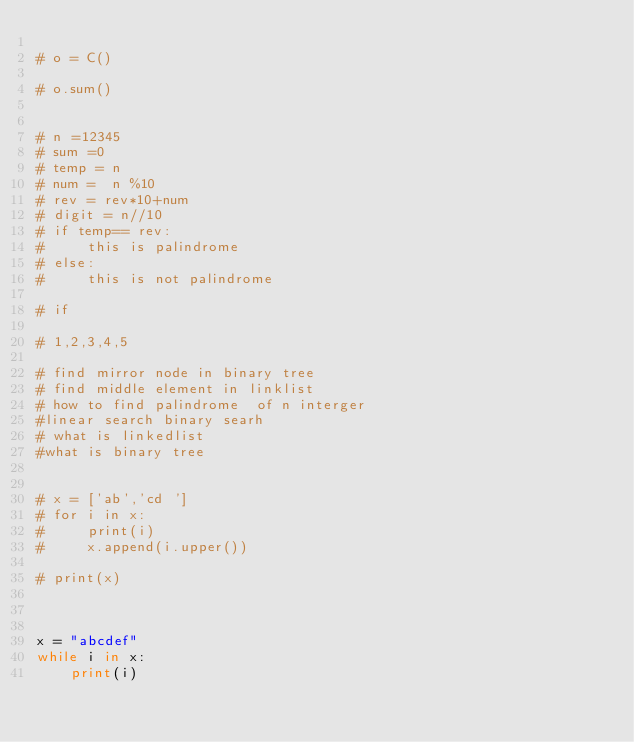Convert code to text. <code><loc_0><loc_0><loc_500><loc_500><_Python_>
# o = C()

# o.sum()


# n =12345
# sum =0
# temp = n
# num =  n %10
# rev = rev*10+num
# digit = n//10
# if temp== rev:
#     this is palindrome
# else:
#     this is not palindrome

# if 

# 1,2,3,4,5

# find mirror node in binary tree
# find middle element in linklist
# how to find palindrome  of n interger
#linear search binary searh
# what is linkedlist
#what is binary tree


# x = ['ab','cd ']
# for i in x:
#     print(i)
#     x.append(i.upper())

# print(x)



x = "abcdef"
while i in x:
    print(i)



</code> 